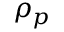Convert formula to latex. <formula><loc_0><loc_0><loc_500><loc_500>\rho _ { p }</formula> 